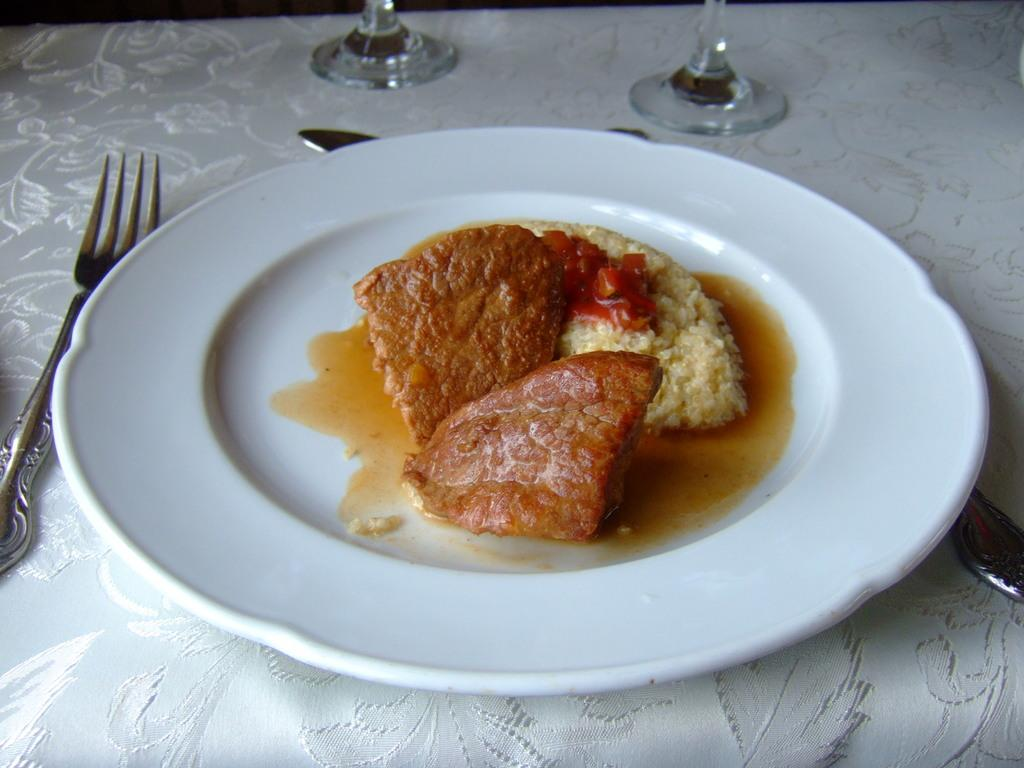What type of food can be seen in the image? There is food in the image, but the specific type is not mentioned. What color is the plate that the food is on? The plate is white in color. What utensil is present in the image? There is a fork in the image. What type of objects are made of glass in the image? The glass objects in the image are not specified. What colors are present in the food? The food has brown, red, and white colors. What type of cloth is in the image? There is a white color cloth in the image. What type of yam is being used as a hair accessory in the image? There is no yam or hair accessory present in the image. What type of cushion is placed on the table in the image? There is no cushion present in the image. 